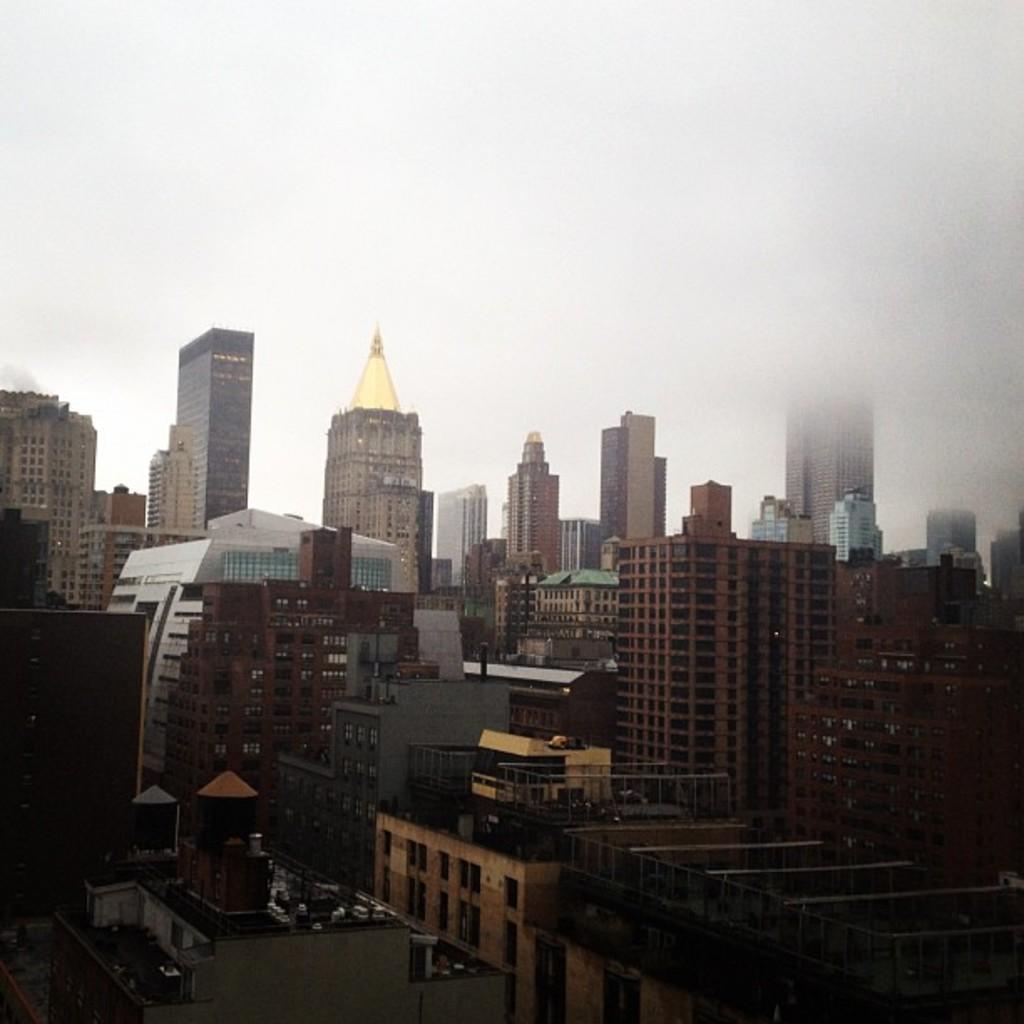In one or two sentences, can you explain what this image depicts? There are buildings and towers. In the background, there is sky. 